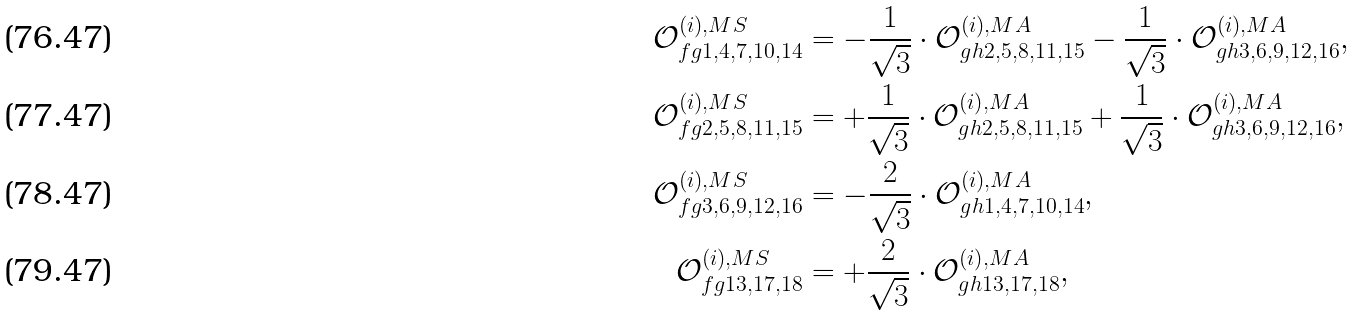<formula> <loc_0><loc_0><loc_500><loc_500>\mathcal { O } ^ { ( i ) , M S } _ { f g 1 , 4 , 7 , 1 0 , 1 4 } & = - \frac { 1 } { \sqrt { 3 } } \cdot \mathcal { O } ^ { ( i ) , M A } _ { g h 2 , 5 , 8 , 1 1 , 1 5 } - \frac { 1 } { \sqrt { 3 } } \cdot \mathcal { O } ^ { ( i ) , M A } _ { g h 3 , 6 , 9 , 1 2 , 1 6 } , \\ \mathcal { O } ^ { ( i ) , M S } _ { f g 2 , 5 , 8 , 1 1 , 1 5 } & = + \frac { 1 } { \sqrt { 3 } } \cdot \mathcal { O } ^ { ( i ) , M A } _ { g h 2 , 5 , 8 , 1 1 , 1 5 } + \frac { 1 } { \sqrt { 3 } } \cdot \mathcal { O } ^ { ( i ) , M A } _ { g h 3 , 6 , 9 , 1 2 , 1 6 } , \\ \mathcal { O } ^ { ( i ) , M S } _ { f g 3 , 6 , 9 , 1 2 , 1 6 } & = - \frac { 2 } { \sqrt { 3 } } \cdot \mathcal { O } ^ { ( i ) , M A } _ { g h 1 , 4 , 7 , 1 0 , 1 4 } , \\ \mathcal { O } ^ { ( i ) , M S } _ { f g 1 3 , 1 7 , 1 8 } & = + \frac { 2 } { \sqrt { 3 } } \cdot \mathcal { O } ^ { ( i ) , M A } _ { g h 1 3 , 1 7 , 1 8 } ,</formula> 